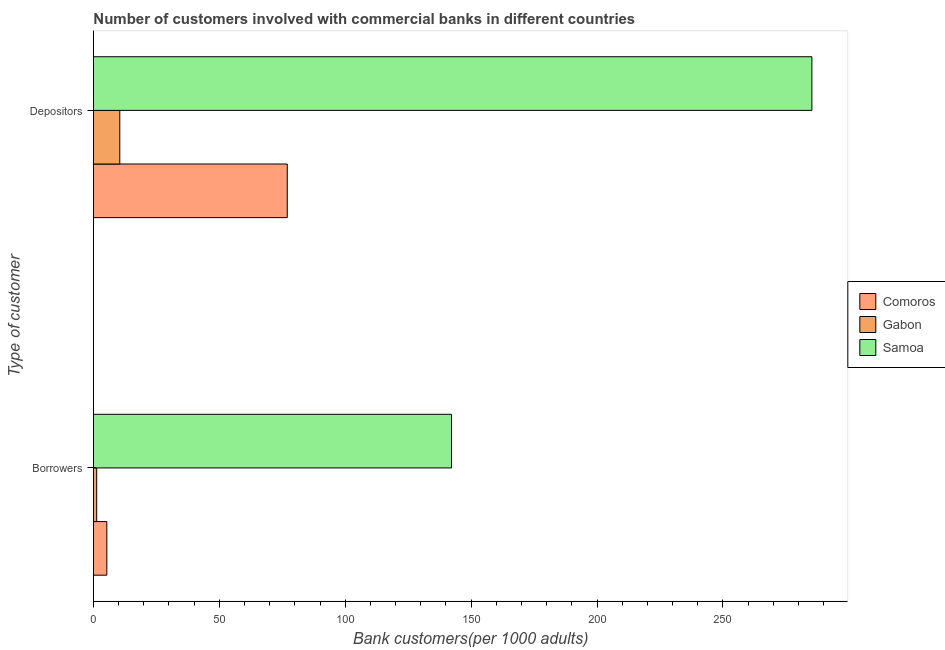How many bars are there on the 2nd tick from the bottom?
Provide a short and direct response. 3. What is the label of the 1st group of bars from the top?
Give a very brief answer. Depositors. What is the number of borrowers in Gabon?
Offer a terse response. 1.28. Across all countries, what is the maximum number of depositors?
Offer a very short reply. 285.32. Across all countries, what is the minimum number of borrowers?
Give a very brief answer. 1.28. In which country was the number of borrowers maximum?
Your answer should be compact. Samoa. In which country was the number of borrowers minimum?
Make the answer very short. Gabon. What is the total number of depositors in the graph?
Give a very brief answer. 372.75. What is the difference between the number of depositors in Samoa and that in Gabon?
Provide a short and direct response. 274.86. What is the difference between the number of borrowers in Samoa and the number of depositors in Gabon?
Provide a short and direct response. 131.73. What is the average number of depositors per country?
Your answer should be compact. 124.25. What is the difference between the number of borrowers and number of depositors in Comoros?
Keep it short and to the point. -71.66. In how many countries, is the number of depositors greater than 130 ?
Make the answer very short. 1. What is the ratio of the number of borrowers in Gabon to that in Samoa?
Offer a terse response. 0.01. What does the 3rd bar from the top in Borrowers represents?
Your answer should be compact. Comoros. What does the 3rd bar from the bottom in Depositors represents?
Keep it short and to the point. Samoa. How many bars are there?
Offer a terse response. 6. Are all the bars in the graph horizontal?
Your response must be concise. Yes. How many countries are there in the graph?
Make the answer very short. 3. Does the graph contain grids?
Provide a succinct answer. No. Where does the legend appear in the graph?
Offer a very short reply. Center right. What is the title of the graph?
Your answer should be compact. Number of customers involved with commercial banks in different countries. Does "Georgia" appear as one of the legend labels in the graph?
Provide a short and direct response. No. What is the label or title of the X-axis?
Provide a short and direct response. Bank customers(per 1000 adults). What is the label or title of the Y-axis?
Your response must be concise. Type of customer. What is the Bank customers(per 1000 adults) in Comoros in Borrowers?
Offer a very short reply. 5.31. What is the Bank customers(per 1000 adults) of Gabon in Borrowers?
Provide a short and direct response. 1.28. What is the Bank customers(per 1000 adults) in Samoa in Borrowers?
Make the answer very short. 142.19. What is the Bank customers(per 1000 adults) of Comoros in Depositors?
Your answer should be compact. 76.97. What is the Bank customers(per 1000 adults) in Gabon in Depositors?
Keep it short and to the point. 10.46. What is the Bank customers(per 1000 adults) of Samoa in Depositors?
Offer a terse response. 285.32. Across all Type of customer, what is the maximum Bank customers(per 1000 adults) in Comoros?
Offer a terse response. 76.97. Across all Type of customer, what is the maximum Bank customers(per 1000 adults) in Gabon?
Offer a terse response. 10.46. Across all Type of customer, what is the maximum Bank customers(per 1000 adults) in Samoa?
Your response must be concise. 285.32. Across all Type of customer, what is the minimum Bank customers(per 1000 adults) in Comoros?
Your answer should be very brief. 5.31. Across all Type of customer, what is the minimum Bank customers(per 1000 adults) in Gabon?
Your answer should be very brief. 1.28. Across all Type of customer, what is the minimum Bank customers(per 1000 adults) in Samoa?
Ensure brevity in your answer.  142.19. What is the total Bank customers(per 1000 adults) of Comoros in the graph?
Make the answer very short. 82.28. What is the total Bank customers(per 1000 adults) of Gabon in the graph?
Offer a terse response. 11.74. What is the total Bank customers(per 1000 adults) of Samoa in the graph?
Offer a very short reply. 427.51. What is the difference between the Bank customers(per 1000 adults) in Comoros in Borrowers and that in Depositors?
Your answer should be compact. -71.66. What is the difference between the Bank customers(per 1000 adults) of Gabon in Borrowers and that in Depositors?
Offer a very short reply. -9.18. What is the difference between the Bank customers(per 1000 adults) in Samoa in Borrowers and that in Depositors?
Your response must be concise. -143.13. What is the difference between the Bank customers(per 1000 adults) of Comoros in Borrowers and the Bank customers(per 1000 adults) of Gabon in Depositors?
Your answer should be very brief. -5.15. What is the difference between the Bank customers(per 1000 adults) of Comoros in Borrowers and the Bank customers(per 1000 adults) of Samoa in Depositors?
Your response must be concise. -280.01. What is the difference between the Bank customers(per 1000 adults) in Gabon in Borrowers and the Bank customers(per 1000 adults) in Samoa in Depositors?
Give a very brief answer. -284.04. What is the average Bank customers(per 1000 adults) in Comoros per Type of customer?
Your answer should be compact. 41.14. What is the average Bank customers(per 1000 adults) in Gabon per Type of customer?
Your answer should be compact. 5.87. What is the average Bank customers(per 1000 adults) of Samoa per Type of customer?
Provide a succinct answer. 213.75. What is the difference between the Bank customers(per 1000 adults) of Comoros and Bank customers(per 1000 adults) of Gabon in Borrowers?
Your response must be concise. 4.03. What is the difference between the Bank customers(per 1000 adults) of Comoros and Bank customers(per 1000 adults) of Samoa in Borrowers?
Give a very brief answer. -136.88. What is the difference between the Bank customers(per 1000 adults) of Gabon and Bank customers(per 1000 adults) of Samoa in Borrowers?
Provide a succinct answer. -140.91. What is the difference between the Bank customers(per 1000 adults) in Comoros and Bank customers(per 1000 adults) in Gabon in Depositors?
Offer a very short reply. 66.51. What is the difference between the Bank customers(per 1000 adults) in Comoros and Bank customers(per 1000 adults) in Samoa in Depositors?
Provide a short and direct response. -208.35. What is the difference between the Bank customers(per 1000 adults) of Gabon and Bank customers(per 1000 adults) of Samoa in Depositors?
Your answer should be compact. -274.86. What is the ratio of the Bank customers(per 1000 adults) of Comoros in Borrowers to that in Depositors?
Provide a short and direct response. 0.07. What is the ratio of the Bank customers(per 1000 adults) in Gabon in Borrowers to that in Depositors?
Ensure brevity in your answer.  0.12. What is the ratio of the Bank customers(per 1000 adults) of Samoa in Borrowers to that in Depositors?
Offer a very short reply. 0.5. What is the difference between the highest and the second highest Bank customers(per 1000 adults) in Comoros?
Keep it short and to the point. 71.66. What is the difference between the highest and the second highest Bank customers(per 1000 adults) of Gabon?
Offer a terse response. 9.18. What is the difference between the highest and the second highest Bank customers(per 1000 adults) of Samoa?
Offer a terse response. 143.13. What is the difference between the highest and the lowest Bank customers(per 1000 adults) of Comoros?
Your answer should be very brief. 71.66. What is the difference between the highest and the lowest Bank customers(per 1000 adults) of Gabon?
Keep it short and to the point. 9.18. What is the difference between the highest and the lowest Bank customers(per 1000 adults) of Samoa?
Provide a short and direct response. 143.13. 